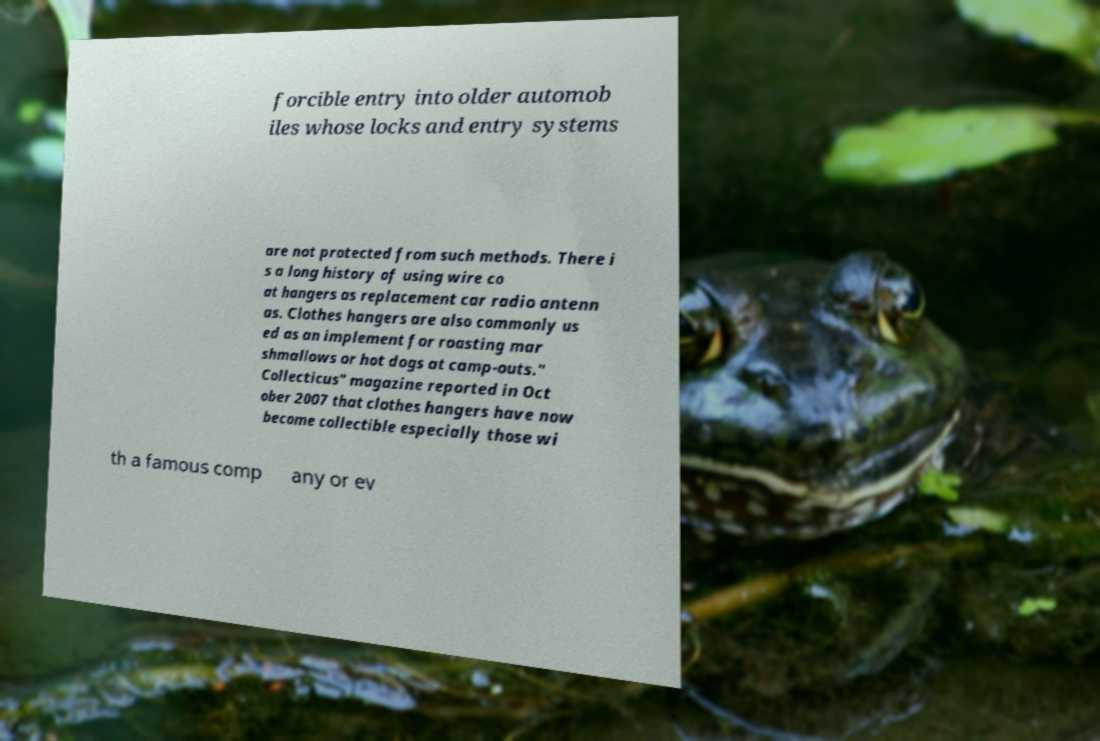I need the written content from this picture converted into text. Can you do that? forcible entry into older automob iles whose locks and entry systems are not protected from such methods. There i s a long history of using wire co at hangers as replacement car radio antenn as. Clothes hangers are also commonly us ed as an implement for roasting mar shmallows or hot dogs at camp-outs." Collecticus" magazine reported in Oct ober 2007 that clothes hangers have now become collectible especially those wi th a famous comp any or ev 